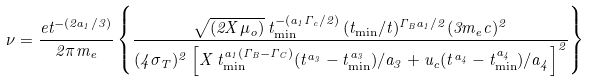<formula> <loc_0><loc_0><loc_500><loc_500>\nu = \frac { e t ^ { - ( 2 a _ { 1 } / 3 ) } } { 2 \pi m _ { e } } \left \{ \frac { \sqrt { ( 2 X \mu _ { o } ) } \, t _ { \min } ^ { - ( a _ { 1 } \Gamma _ { c } / 2 ) } \, ( t _ { \min } / t ) ^ { \Gamma _ { B } a _ { 1 } / 2 } ( 3 m _ { e } c ) ^ { 2 } } { ( 4 \sigma _ { T } ) ^ { 2 } \left [ X \, t _ { \min } ^ { a _ { 1 } ( \Gamma _ { B } - \Gamma _ { C } ) } ( t ^ { a _ { 3 } } - t _ { \min } ^ { a _ { 3 } } ) / a _ { 3 } + u _ { c } ( t ^ { a _ { 4 } } - t _ { \min } ^ { a _ { 4 } } ) / a _ { 4 } \right ] ^ { 2 } } \right \}</formula> 